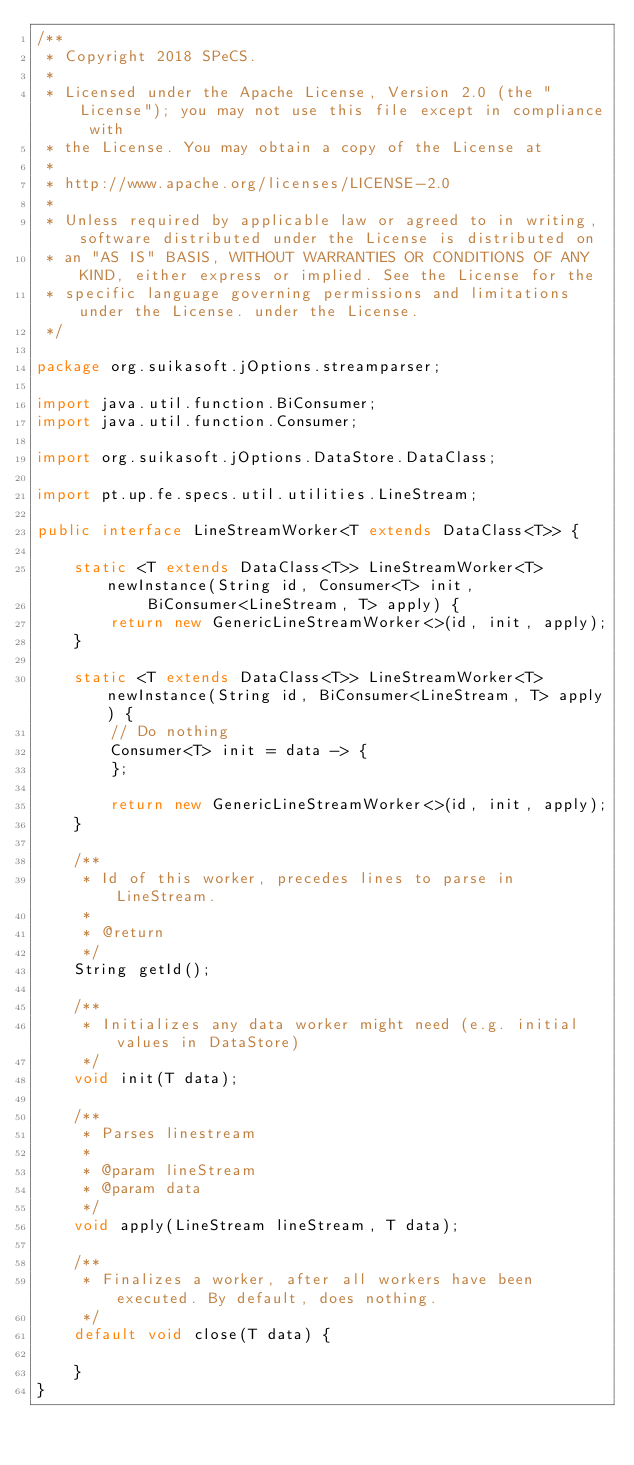<code> <loc_0><loc_0><loc_500><loc_500><_Java_>/**
 * Copyright 2018 SPeCS.
 * 
 * Licensed under the Apache License, Version 2.0 (the "License"); you may not use this file except in compliance with
 * the License. You may obtain a copy of the License at
 * 
 * http://www.apache.org/licenses/LICENSE-2.0
 * 
 * Unless required by applicable law or agreed to in writing, software distributed under the License is distributed on
 * an "AS IS" BASIS, WITHOUT WARRANTIES OR CONDITIONS OF ANY KIND, either express or implied. See the License for the
 * specific language governing permissions and limitations under the License. under the License.
 */

package org.suikasoft.jOptions.streamparser;

import java.util.function.BiConsumer;
import java.util.function.Consumer;

import org.suikasoft.jOptions.DataStore.DataClass;

import pt.up.fe.specs.util.utilities.LineStream;

public interface LineStreamWorker<T extends DataClass<T>> {

    static <T extends DataClass<T>> LineStreamWorker<T> newInstance(String id, Consumer<T> init,
            BiConsumer<LineStream, T> apply) {
        return new GenericLineStreamWorker<>(id, init, apply);
    }

    static <T extends DataClass<T>> LineStreamWorker<T> newInstance(String id, BiConsumer<LineStream, T> apply) {
        // Do nothing
        Consumer<T> init = data -> {
        };

        return new GenericLineStreamWorker<>(id, init, apply);
    }

    /**
     * Id of this worker, precedes lines to parse in LineStream.
     * 
     * @return
     */
    String getId();

    /**
     * Initializes any data worker might need (e.g. initial values in DataStore)
     */
    void init(T data);

    /**
     * Parses linestream
     * 
     * @param lineStream
     * @param data
     */
    void apply(LineStream lineStream, T data);

    /**
     * Finalizes a worker, after all workers have been executed. By default, does nothing.
     */
    default void close(T data) {

    }
}
</code> 